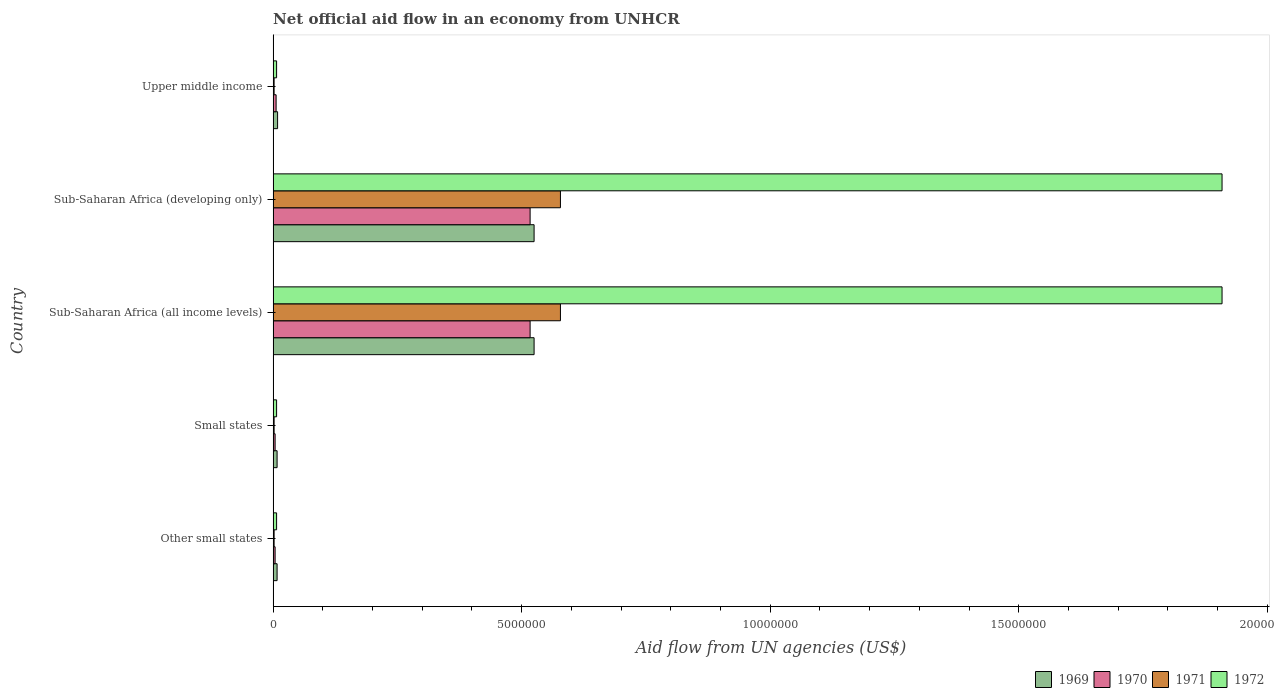How many different coloured bars are there?
Your answer should be compact. 4. How many groups of bars are there?
Offer a terse response. 5. Are the number of bars per tick equal to the number of legend labels?
Your response must be concise. Yes. How many bars are there on the 5th tick from the top?
Keep it short and to the point. 4. How many bars are there on the 5th tick from the bottom?
Your response must be concise. 4. What is the label of the 1st group of bars from the top?
Ensure brevity in your answer.  Upper middle income. What is the net official aid flow in 1970 in Sub-Saharan Africa (developing only)?
Offer a terse response. 5.17e+06. Across all countries, what is the maximum net official aid flow in 1970?
Ensure brevity in your answer.  5.17e+06. In which country was the net official aid flow in 1972 maximum?
Make the answer very short. Sub-Saharan Africa (all income levels). In which country was the net official aid flow in 1972 minimum?
Offer a terse response. Other small states. What is the total net official aid flow in 1971 in the graph?
Keep it short and to the point. 1.16e+07. What is the difference between the net official aid flow in 1970 in Other small states and that in Sub-Saharan Africa (developing only)?
Offer a terse response. -5.13e+06. What is the average net official aid flow in 1972 per country?
Offer a terse response. 7.68e+06. What is the ratio of the net official aid flow in 1970 in Small states to that in Sub-Saharan Africa (all income levels)?
Offer a very short reply. 0.01. What is the difference between the highest and the lowest net official aid flow in 1971?
Give a very brief answer. 5.76e+06. In how many countries, is the net official aid flow in 1972 greater than the average net official aid flow in 1972 taken over all countries?
Offer a very short reply. 2. Is it the case that in every country, the sum of the net official aid flow in 1971 and net official aid flow in 1970 is greater than the sum of net official aid flow in 1972 and net official aid flow in 1969?
Offer a terse response. No. What does the 3rd bar from the top in Sub-Saharan Africa (all income levels) represents?
Provide a short and direct response. 1970. What does the 4th bar from the bottom in Other small states represents?
Provide a short and direct response. 1972. Is it the case that in every country, the sum of the net official aid flow in 1969 and net official aid flow in 1972 is greater than the net official aid flow in 1971?
Offer a very short reply. Yes. How many bars are there?
Keep it short and to the point. 20. Does the graph contain grids?
Make the answer very short. No. How are the legend labels stacked?
Offer a very short reply. Horizontal. What is the title of the graph?
Offer a terse response. Net official aid flow in an economy from UNHCR. What is the label or title of the X-axis?
Your answer should be compact. Aid flow from UN agencies (US$). What is the label or title of the Y-axis?
Give a very brief answer. Country. What is the Aid flow from UN agencies (US$) in 1969 in Other small states?
Your answer should be very brief. 8.00e+04. What is the Aid flow from UN agencies (US$) in 1971 in Other small states?
Offer a very short reply. 2.00e+04. What is the Aid flow from UN agencies (US$) of 1969 in Small states?
Your response must be concise. 8.00e+04. What is the Aid flow from UN agencies (US$) of 1970 in Small states?
Give a very brief answer. 4.00e+04. What is the Aid flow from UN agencies (US$) in 1971 in Small states?
Provide a succinct answer. 2.00e+04. What is the Aid flow from UN agencies (US$) in 1972 in Small states?
Keep it short and to the point. 7.00e+04. What is the Aid flow from UN agencies (US$) of 1969 in Sub-Saharan Africa (all income levels)?
Provide a short and direct response. 5.25e+06. What is the Aid flow from UN agencies (US$) of 1970 in Sub-Saharan Africa (all income levels)?
Offer a very short reply. 5.17e+06. What is the Aid flow from UN agencies (US$) in 1971 in Sub-Saharan Africa (all income levels)?
Offer a terse response. 5.78e+06. What is the Aid flow from UN agencies (US$) in 1972 in Sub-Saharan Africa (all income levels)?
Keep it short and to the point. 1.91e+07. What is the Aid flow from UN agencies (US$) in 1969 in Sub-Saharan Africa (developing only)?
Give a very brief answer. 5.25e+06. What is the Aid flow from UN agencies (US$) in 1970 in Sub-Saharan Africa (developing only)?
Your answer should be compact. 5.17e+06. What is the Aid flow from UN agencies (US$) of 1971 in Sub-Saharan Africa (developing only)?
Your answer should be compact. 5.78e+06. What is the Aid flow from UN agencies (US$) in 1972 in Sub-Saharan Africa (developing only)?
Make the answer very short. 1.91e+07. What is the Aid flow from UN agencies (US$) of 1971 in Upper middle income?
Your answer should be very brief. 2.00e+04. Across all countries, what is the maximum Aid flow from UN agencies (US$) in 1969?
Your answer should be compact. 5.25e+06. Across all countries, what is the maximum Aid flow from UN agencies (US$) of 1970?
Make the answer very short. 5.17e+06. Across all countries, what is the maximum Aid flow from UN agencies (US$) in 1971?
Provide a succinct answer. 5.78e+06. Across all countries, what is the maximum Aid flow from UN agencies (US$) of 1972?
Make the answer very short. 1.91e+07. Across all countries, what is the minimum Aid flow from UN agencies (US$) in 1969?
Ensure brevity in your answer.  8.00e+04. What is the total Aid flow from UN agencies (US$) of 1969 in the graph?
Your answer should be compact. 1.08e+07. What is the total Aid flow from UN agencies (US$) in 1970 in the graph?
Offer a terse response. 1.05e+07. What is the total Aid flow from UN agencies (US$) of 1971 in the graph?
Provide a succinct answer. 1.16e+07. What is the total Aid flow from UN agencies (US$) in 1972 in the graph?
Your answer should be very brief. 3.84e+07. What is the difference between the Aid flow from UN agencies (US$) in 1971 in Other small states and that in Small states?
Give a very brief answer. 0. What is the difference between the Aid flow from UN agencies (US$) of 1969 in Other small states and that in Sub-Saharan Africa (all income levels)?
Make the answer very short. -5.17e+06. What is the difference between the Aid flow from UN agencies (US$) of 1970 in Other small states and that in Sub-Saharan Africa (all income levels)?
Offer a terse response. -5.13e+06. What is the difference between the Aid flow from UN agencies (US$) of 1971 in Other small states and that in Sub-Saharan Africa (all income levels)?
Offer a very short reply. -5.76e+06. What is the difference between the Aid flow from UN agencies (US$) of 1972 in Other small states and that in Sub-Saharan Africa (all income levels)?
Your answer should be very brief. -1.90e+07. What is the difference between the Aid flow from UN agencies (US$) of 1969 in Other small states and that in Sub-Saharan Africa (developing only)?
Provide a succinct answer. -5.17e+06. What is the difference between the Aid flow from UN agencies (US$) in 1970 in Other small states and that in Sub-Saharan Africa (developing only)?
Your answer should be very brief. -5.13e+06. What is the difference between the Aid flow from UN agencies (US$) of 1971 in Other small states and that in Sub-Saharan Africa (developing only)?
Make the answer very short. -5.76e+06. What is the difference between the Aid flow from UN agencies (US$) in 1972 in Other small states and that in Sub-Saharan Africa (developing only)?
Provide a succinct answer. -1.90e+07. What is the difference between the Aid flow from UN agencies (US$) of 1970 in Other small states and that in Upper middle income?
Make the answer very short. -2.00e+04. What is the difference between the Aid flow from UN agencies (US$) of 1969 in Small states and that in Sub-Saharan Africa (all income levels)?
Provide a short and direct response. -5.17e+06. What is the difference between the Aid flow from UN agencies (US$) of 1970 in Small states and that in Sub-Saharan Africa (all income levels)?
Offer a very short reply. -5.13e+06. What is the difference between the Aid flow from UN agencies (US$) in 1971 in Small states and that in Sub-Saharan Africa (all income levels)?
Ensure brevity in your answer.  -5.76e+06. What is the difference between the Aid flow from UN agencies (US$) in 1972 in Small states and that in Sub-Saharan Africa (all income levels)?
Make the answer very short. -1.90e+07. What is the difference between the Aid flow from UN agencies (US$) of 1969 in Small states and that in Sub-Saharan Africa (developing only)?
Ensure brevity in your answer.  -5.17e+06. What is the difference between the Aid flow from UN agencies (US$) in 1970 in Small states and that in Sub-Saharan Africa (developing only)?
Make the answer very short. -5.13e+06. What is the difference between the Aid flow from UN agencies (US$) of 1971 in Small states and that in Sub-Saharan Africa (developing only)?
Your response must be concise. -5.76e+06. What is the difference between the Aid flow from UN agencies (US$) in 1972 in Small states and that in Sub-Saharan Africa (developing only)?
Ensure brevity in your answer.  -1.90e+07. What is the difference between the Aid flow from UN agencies (US$) of 1972 in Small states and that in Upper middle income?
Provide a short and direct response. 0. What is the difference between the Aid flow from UN agencies (US$) in 1969 in Sub-Saharan Africa (all income levels) and that in Sub-Saharan Africa (developing only)?
Ensure brevity in your answer.  0. What is the difference between the Aid flow from UN agencies (US$) in 1970 in Sub-Saharan Africa (all income levels) and that in Sub-Saharan Africa (developing only)?
Ensure brevity in your answer.  0. What is the difference between the Aid flow from UN agencies (US$) of 1969 in Sub-Saharan Africa (all income levels) and that in Upper middle income?
Provide a short and direct response. 5.16e+06. What is the difference between the Aid flow from UN agencies (US$) of 1970 in Sub-Saharan Africa (all income levels) and that in Upper middle income?
Offer a very short reply. 5.11e+06. What is the difference between the Aid flow from UN agencies (US$) in 1971 in Sub-Saharan Africa (all income levels) and that in Upper middle income?
Offer a very short reply. 5.76e+06. What is the difference between the Aid flow from UN agencies (US$) in 1972 in Sub-Saharan Africa (all income levels) and that in Upper middle income?
Provide a succinct answer. 1.90e+07. What is the difference between the Aid flow from UN agencies (US$) of 1969 in Sub-Saharan Africa (developing only) and that in Upper middle income?
Your answer should be very brief. 5.16e+06. What is the difference between the Aid flow from UN agencies (US$) of 1970 in Sub-Saharan Africa (developing only) and that in Upper middle income?
Offer a very short reply. 5.11e+06. What is the difference between the Aid flow from UN agencies (US$) in 1971 in Sub-Saharan Africa (developing only) and that in Upper middle income?
Offer a terse response. 5.76e+06. What is the difference between the Aid flow from UN agencies (US$) in 1972 in Sub-Saharan Africa (developing only) and that in Upper middle income?
Keep it short and to the point. 1.90e+07. What is the difference between the Aid flow from UN agencies (US$) of 1969 in Other small states and the Aid flow from UN agencies (US$) of 1971 in Small states?
Your answer should be very brief. 6.00e+04. What is the difference between the Aid flow from UN agencies (US$) in 1970 in Other small states and the Aid flow from UN agencies (US$) in 1971 in Small states?
Give a very brief answer. 2.00e+04. What is the difference between the Aid flow from UN agencies (US$) in 1970 in Other small states and the Aid flow from UN agencies (US$) in 1972 in Small states?
Ensure brevity in your answer.  -3.00e+04. What is the difference between the Aid flow from UN agencies (US$) of 1969 in Other small states and the Aid flow from UN agencies (US$) of 1970 in Sub-Saharan Africa (all income levels)?
Your response must be concise. -5.09e+06. What is the difference between the Aid flow from UN agencies (US$) of 1969 in Other small states and the Aid flow from UN agencies (US$) of 1971 in Sub-Saharan Africa (all income levels)?
Make the answer very short. -5.70e+06. What is the difference between the Aid flow from UN agencies (US$) of 1969 in Other small states and the Aid flow from UN agencies (US$) of 1972 in Sub-Saharan Africa (all income levels)?
Provide a succinct answer. -1.90e+07. What is the difference between the Aid flow from UN agencies (US$) of 1970 in Other small states and the Aid flow from UN agencies (US$) of 1971 in Sub-Saharan Africa (all income levels)?
Your answer should be very brief. -5.74e+06. What is the difference between the Aid flow from UN agencies (US$) in 1970 in Other small states and the Aid flow from UN agencies (US$) in 1972 in Sub-Saharan Africa (all income levels)?
Offer a very short reply. -1.90e+07. What is the difference between the Aid flow from UN agencies (US$) in 1971 in Other small states and the Aid flow from UN agencies (US$) in 1972 in Sub-Saharan Africa (all income levels)?
Make the answer very short. -1.91e+07. What is the difference between the Aid flow from UN agencies (US$) of 1969 in Other small states and the Aid flow from UN agencies (US$) of 1970 in Sub-Saharan Africa (developing only)?
Provide a short and direct response. -5.09e+06. What is the difference between the Aid flow from UN agencies (US$) of 1969 in Other small states and the Aid flow from UN agencies (US$) of 1971 in Sub-Saharan Africa (developing only)?
Give a very brief answer. -5.70e+06. What is the difference between the Aid flow from UN agencies (US$) in 1969 in Other small states and the Aid flow from UN agencies (US$) in 1972 in Sub-Saharan Africa (developing only)?
Your answer should be compact. -1.90e+07. What is the difference between the Aid flow from UN agencies (US$) in 1970 in Other small states and the Aid flow from UN agencies (US$) in 1971 in Sub-Saharan Africa (developing only)?
Provide a short and direct response. -5.74e+06. What is the difference between the Aid flow from UN agencies (US$) of 1970 in Other small states and the Aid flow from UN agencies (US$) of 1972 in Sub-Saharan Africa (developing only)?
Keep it short and to the point. -1.90e+07. What is the difference between the Aid flow from UN agencies (US$) in 1971 in Other small states and the Aid flow from UN agencies (US$) in 1972 in Sub-Saharan Africa (developing only)?
Make the answer very short. -1.91e+07. What is the difference between the Aid flow from UN agencies (US$) in 1969 in Other small states and the Aid flow from UN agencies (US$) in 1970 in Upper middle income?
Keep it short and to the point. 2.00e+04. What is the difference between the Aid flow from UN agencies (US$) of 1969 in Other small states and the Aid flow from UN agencies (US$) of 1972 in Upper middle income?
Provide a short and direct response. 10000. What is the difference between the Aid flow from UN agencies (US$) of 1969 in Small states and the Aid flow from UN agencies (US$) of 1970 in Sub-Saharan Africa (all income levels)?
Provide a succinct answer. -5.09e+06. What is the difference between the Aid flow from UN agencies (US$) in 1969 in Small states and the Aid flow from UN agencies (US$) in 1971 in Sub-Saharan Africa (all income levels)?
Your answer should be very brief. -5.70e+06. What is the difference between the Aid flow from UN agencies (US$) of 1969 in Small states and the Aid flow from UN agencies (US$) of 1972 in Sub-Saharan Africa (all income levels)?
Your answer should be compact. -1.90e+07. What is the difference between the Aid flow from UN agencies (US$) of 1970 in Small states and the Aid flow from UN agencies (US$) of 1971 in Sub-Saharan Africa (all income levels)?
Provide a short and direct response. -5.74e+06. What is the difference between the Aid flow from UN agencies (US$) of 1970 in Small states and the Aid flow from UN agencies (US$) of 1972 in Sub-Saharan Africa (all income levels)?
Offer a terse response. -1.90e+07. What is the difference between the Aid flow from UN agencies (US$) in 1971 in Small states and the Aid flow from UN agencies (US$) in 1972 in Sub-Saharan Africa (all income levels)?
Keep it short and to the point. -1.91e+07. What is the difference between the Aid flow from UN agencies (US$) in 1969 in Small states and the Aid flow from UN agencies (US$) in 1970 in Sub-Saharan Africa (developing only)?
Ensure brevity in your answer.  -5.09e+06. What is the difference between the Aid flow from UN agencies (US$) in 1969 in Small states and the Aid flow from UN agencies (US$) in 1971 in Sub-Saharan Africa (developing only)?
Your response must be concise. -5.70e+06. What is the difference between the Aid flow from UN agencies (US$) of 1969 in Small states and the Aid flow from UN agencies (US$) of 1972 in Sub-Saharan Africa (developing only)?
Offer a terse response. -1.90e+07. What is the difference between the Aid flow from UN agencies (US$) in 1970 in Small states and the Aid flow from UN agencies (US$) in 1971 in Sub-Saharan Africa (developing only)?
Keep it short and to the point. -5.74e+06. What is the difference between the Aid flow from UN agencies (US$) in 1970 in Small states and the Aid flow from UN agencies (US$) in 1972 in Sub-Saharan Africa (developing only)?
Offer a very short reply. -1.90e+07. What is the difference between the Aid flow from UN agencies (US$) of 1971 in Small states and the Aid flow from UN agencies (US$) of 1972 in Sub-Saharan Africa (developing only)?
Provide a short and direct response. -1.91e+07. What is the difference between the Aid flow from UN agencies (US$) of 1969 in Small states and the Aid flow from UN agencies (US$) of 1971 in Upper middle income?
Your answer should be very brief. 6.00e+04. What is the difference between the Aid flow from UN agencies (US$) of 1970 in Small states and the Aid flow from UN agencies (US$) of 1971 in Upper middle income?
Offer a terse response. 2.00e+04. What is the difference between the Aid flow from UN agencies (US$) in 1970 in Small states and the Aid flow from UN agencies (US$) in 1972 in Upper middle income?
Your answer should be very brief. -3.00e+04. What is the difference between the Aid flow from UN agencies (US$) in 1971 in Small states and the Aid flow from UN agencies (US$) in 1972 in Upper middle income?
Offer a very short reply. -5.00e+04. What is the difference between the Aid flow from UN agencies (US$) in 1969 in Sub-Saharan Africa (all income levels) and the Aid flow from UN agencies (US$) in 1971 in Sub-Saharan Africa (developing only)?
Your response must be concise. -5.30e+05. What is the difference between the Aid flow from UN agencies (US$) of 1969 in Sub-Saharan Africa (all income levels) and the Aid flow from UN agencies (US$) of 1972 in Sub-Saharan Africa (developing only)?
Ensure brevity in your answer.  -1.38e+07. What is the difference between the Aid flow from UN agencies (US$) in 1970 in Sub-Saharan Africa (all income levels) and the Aid flow from UN agencies (US$) in 1971 in Sub-Saharan Africa (developing only)?
Offer a terse response. -6.10e+05. What is the difference between the Aid flow from UN agencies (US$) of 1970 in Sub-Saharan Africa (all income levels) and the Aid flow from UN agencies (US$) of 1972 in Sub-Saharan Africa (developing only)?
Offer a very short reply. -1.39e+07. What is the difference between the Aid flow from UN agencies (US$) in 1971 in Sub-Saharan Africa (all income levels) and the Aid flow from UN agencies (US$) in 1972 in Sub-Saharan Africa (developing only)?
Your response must be concise. -1.33e+07. What is the difference between the Aid flow from UN agencies (US$) in 1969 in Sub-Saharan Africa (all income levels) and the Aid flow from UN agencies (US$) in 1970 in Upper middle income?
Your response must be concise. 5.19e+06. What is the difference between the Aid flow from UN agencies (US$) of 1969 in Sub-Saharan Africa (all income levels) and the Aid flow from UN agencies (US$) of 1971 in Upper middle income?
Provide a succinct answer. 5.23e+06. What is the difference between the Aid flow from UN agencies (US$) in 1969 in Sub-Saharan Africa (all income levels) and the Aid flow from UN agencies (US$) in 1972 in Upper middle income?
Your response must be concise. 5.18e+06. What is the difference between the Aid flow from UN agencies (US$) of 1970 in Sub-Saharan Africa (all income levels) and the Aid flow from UN agencies (US$) of 1971 in Upper middle income?
Your response must be concise. 5.15e+06. What is the difference between the Aid flow from UN agencies (US$) in 1970 in Sub-Saharan Africa (all income levels) and the Aid flow from UN agencies (US$) in 1972 in Upper middle income?
Give a very brief answer. 5.10e+06. What is the difference between the Aid flow from UN agencies (US$) of 1971 in Sub-Saharan Africa (all income levels) and the Aid flow from UN agencies (US$) of 1972 in Upper middle income?
Make the answer very short. 5.71e+06. What is the difference between the Aid flow from UN agencies (US$) in 1969 in Sub-Saharan Africa (developing only) and the Aid flow from UN agencies (US$) in 1970 in Upper middle income?
Ensure brevity in your answer.  5.19e+06. What is the difference between the Aid flow from UN agencies (US$) in 1969 in Sub-Saharan Africa (developing only) and the Aid flow from UN agencies (US$) in 1971 in Upper middle income?
Ensure brevity in your answer.  5.23e+06. What is the difference between the Aid flow from UN agencies (US$) in 1969 in Sub-Saharan Africa (developing only) and the Aid flow from UN agencies (US$) in 1972 in Upper middle income?
Provide a succinct answer. 5.18e+06. What is the difference between the Aid flow from UN agencies (US$) in 1970 in Sub-Saharan Africa (developing only) and the Aid flow from UN agencies (US$) in 1971 in Upper middle income?
Keep it short and to the point. 5.15e+06. What is the difference between the Aid flow from UN agencies (US$) in 1970 in Sub-Saharan Africa (developing only) and the Aid flow from UN agencies (US$) in 1972 in Upper middle income?
Your answer should be compact. 5.10e+06. What is the difference between the Aid flow from UN agencies (US$) of 1971 in Sub-Saharan Africa (developing only) and the Aid flow from UN agencies (US$) of 1972 in Upper middle income?
Offer a terse response. 5.71e+06. What is the average Aid flow from UN agencies (US$) in 1969 per country?
Your answer should be compact. 2.15e+06. What is the average Aid flow from UN agencies (US$) of 1970 per country?
Keep it short and to the point. 2.10e+06. What is the average Aid flow from UN agencies (US$) in 1971 per country?
Provide a short and direct response. 2.32e+06. What is the average Aid flow from UN agencies (US$) of 1972 per country?
Provide a short and direct response. 7.68e+06. What is the difference between the Aid flow from UN agencies (US$) in 1969 and Aid flow from UN agencies (US$) in 1970 in Other small states?
Provide a succinct answer. 4.00e+04. What is the difference between the Aid flow from UN agencies (US$) in 1969 and Aid flow from UN agencies (US$) in 1971 in Other small states?
Keep it short and to the point. 6.00e+04. What is the difference between the Aid flow from UN agencies (US$) of 1969 and Aid flow from UN agencies (US$) of 1972 in Other small states?
Keep it short and to the point. 10000. What is the difference between the Aid flow from UN agencies (US$) of 1970 and Aid flow from UN agencies (US$) of 1971 in Other small states?
Ensure brevity in your answer.  2.00e+04. What is the difference between the Aid flow from UN agencies (US$) in 1971 and Aid flow from UN agencies (US$) in 1972 in Other small states?
Offer a very short reply. -5.00e+04. What is the difference between the Aid flow from UN agencies (US$) in 1969 and Aid flow from UN agencies (US$) in 1970 in Small states?
Ensure brevity in your answer.  4.00e+04. What is the difference between the Aid flow from UN agencies (US$) of 1969 and Aid flow from UN agencies (US$) of 1971 in Small states?
Your answer should be compact. 6.00e+04. What is the difference between the Aid flow from UN agencies (US$) in 1970 and Aid flow from UN agencies (US$) in 1971 in Small states?
Your answer should be compact. 2.00e+04. What is the difference between the Aid flow from UN agencies (US$) in 1969 and Aid flow from UN agencies (US$) in 1971 in Sub-Saharan Africa (all income levels)?
Your response must be concise. -5.30e+05. What is the difference between the Aid flow from UN agencies (US$) in 1969 and Aid flow from UN agencies (US$) in 1972 in Sub-Saharan Africa (all income levels)?
Provide a short and direct response. -1.38e+07. What is the difference between the Aid flow from UN agencies (US$) in 1970 and Aid flow from UN agencies (US$) in 1971 in Sub-Saharan Africa (all income levels)?
Offer a very short reply. -6.10e+05. What is the difference between the Aid flow from UN agencies (US$) of 1970 and Aid flow from UN agencies (US$) of 1972 in Sub-Saharan Africa (all income levels)?
Keep it short and to the point. -1.39e+07. What is the difference between the Aid flow from UN agencies (US$) of 1971 and Aid flow from UN agencies (US$) of 1972 in Sub-Saharan Africa (all income levels)?
Provide a succinct answer. -1.33e+07. What is the difference between the Aid flow from UN agencies (US$) of 1969 and Aid flow from UN agencies (US$) of 1970 in Sub-Saharan Africa (developing only)?
Offer a terse response. 8.00e+04. What is the difference between the Aid flow from UN agencies (US$) of 1969 and Aid flow from UN agencies (US$) of 1971 in Sub-Saharan Africa (developing only)?
Keep it short and to the point. -5.30e+05. What is the difference between the Aid flow from UN agencies (US$) in 1969 and Aid flow from UN agencies (US$) in 1972 in Sub-Saharan Africa (developing only)?
Your answer should be very brief. -1.38e+07. What is the difference between the Aid flow from UN agencies (US$) of 1970 and Aid flow from UN agencies (US$) of 1971 in Sub-Saharan Africa (developing only)?
Offer a very short reply. -6.10e+05. What is the difference between the Aid flow from UN agencies (US$) in 1970 and Aid flow from UN agencies (US$) in 1972 in Sub-Saharan Africa (developing only)?
Give a very brief answer. -1.39e+07. What is the difference between the Aid flow from UN agencies (US$) of 1971 and Aid flow from UN agencies (US$) of 1972 in Sub-Saharan Africa (developing only)?
Keep it short and to the point. -1.33e+07. What is the difference between the Aid flow from UN agencies (US$) of 1969 and Aid flow from UN agencies (US$) of 1970 in Upper middle income?
Your answer should be very brief. 3.00e+04. What is the difference between the Aid flow from UN agencies (US$) of 1969 and Aid flow from UN agencies (US$) of 1972 in Upper middle income?
Offer a very short reply. 2.00e+04. What is the difference between the Aid flow from UN agencies (US$) in 1970 and Aid flow from UN agencies (US$) in 1971 in Upper middle income?
Provide a short and direct response. 4.00e+04. What is the difference between the Aid flow from UN agencies (US$) of 1971 and Aid flow from UN agencies (US$) of 1972 in Upper middle income?
Provide a succinct answer. -5.00e+04. What is the ratio of the Aid flow from UN agencies (US$) of 1969 in Other small states to that in Small states?
Ensure brevity in your answer.  1. What is the ratio of the Aid flow from UN agencies (US$) of 1970 in Other small states to that in Small states?
Provide a succinct answer. 1. What is the ratio of the Aid flow from UN agencies (US$) in 1971 in Other small states to that in Small states?
Your answer should be compact. 1. What is the ratio of the Aid flow from UN agencies (US$) in 1972 in Other small states to that in Small states?
Offer a terse response. 1. What is the ratio of the Aid flow from UN agencies (US$) in 1969 in Other small states to that in Sub-Saharan Africa (all income levels)?
Ensure brevity in your answer.  0.02. What is the ratio of the Aid flow from UN agencies (US$) of 1970 in Other small states to that in Sub-Saharan Africa (all income levels)?
Offer a very short reply. 0.01. What is the ratio of the Aid flow from UN agencies (US$) of 1971 in Other small states to that in Sub-Saharan Africa (all income levels)?
Keep it short and to the point. 0. What is the ratio of the Aid flow from UN agencies (US$) of 1972 in Other small states to that in Sub-Saharan Africa (all income levels)?
Keep it short and to the point. 0. What is the ratio of the Aid flow from UN agencies (US$) of 1969 in Other small states to that in Sub-Saharan Africa (developing only)?
Give a very brief answer. 0.02. What is the ratio of the Aid flow from UN agencies (US$) in 1970 in Other small states to that in Sub-Saharan Africa (developing only)?
Your answer should be compact. 0.01. What is the ratio of the Aid flow from UN agencies (US$) of 1971 in Other small states to that in Sub-Saharan Africa (developing only)?
Make the answer very short. 0. What is the ratio of the Aid flow from UN agencies (US$) in 1972 in Other small states to that in Sub-Saharan Africa (developing only)?
Provide a short and direct response. 0. What is the ratio of the Aid flow from UN agencies (US$) in 1969 in Other small states to that in Upper middle income?
Give a very brief answer. 0.89. What is the ratio of the Aid flow from UN agencies (US$) of 1970 in Other small states to that in Upper middle income?
Make the answer very short. 0.67. What is the ratio of the Aid flow from UN agencies (US$) in 1971 in Other small states to that in Upper middle income?
Offer a terse response. 1. What is the ratio of the Aid flow from UN agencies (US$) in 1972 in Other small states to that in Upper middle income?
Keep it short and to the point. 1. What is the ratio of the Aid flow from UN agencies (US$) of 1969 in Small states to that in Sub-Saharan Africa (all income levels)?
Offer a terse response. 0.02. What is the ratio of the Aid flow from UN agencies (US$) in 1970 in Small states to that in Sub-Saharan Africa (all income levels)?
Your answer should be very brief. 0.01. What is the ratio of the Aid flow from UN agencies (US$) of 1971 in Small states to that in Sub-Saharan Africa (all income levels)?
Provide a succinct answer. 0. What is the ratio of the Aid flow from UN agencies (US$) in 1972 in Small states to that in Sub-Saharan Africa (all income levels)?
Offer a very short reply. 0. What is the ratio of the Aid flow from UN agencies (US$) of 1969 in Small states to that in Sub-Saharan Africa (developing only)?
Give a very brief answer. 0.02. What is the ratio of the Aid flow from UN agencies (US$) of 1970 in Small states to that in Sub-Saharan Africa (developing only)?
Your answer should be very brief. 0.01. What is the ratio of the Aid flow from UN agencies (US$) in 1971 in Small states to that in Sub-Saharan Africa (developing only)?
Provide a short and direct response. 0. What is the ratio of the Aid flow from UN agencies (US$) of 1972 in Small states to that in Sub-Saharan Africa (developing only)?
Your answer should be very brief. 0. What is the ratio of the Aid flow from UN agencies (US$) of 1970 in Small states to that in Upper middle income?
Your answer should be compact. 0.67. What is the ratio of the Aid flow from UN agencies (US$) of 1972 in Small states to that in Upper middle income?
Provide a succinct answer. 1. What is the ratio of the Aid flow from UN agencies (US$) in 1970 in Sub-Saharan Africa (all income levels) to that in Sub-Saharan Africa (developing only)?
Your response must be concise. 1. What is the ratio of the Aid flow from UN agencies (US$) of 1972 in Sub-Saharan Africa (all income levels) to that in Sub-Saharan Africa (developing only)?
Keep it short and to the point. 1. What is the ratio of the Aid flow from UN agencies (US$) in 1969 in Sub-Saharan Africa (all income levels) to that in Upper middle income?
Offer a very short reply. 58.33. What is the ratio of the Aid flow from UN agencies (US$) of 1970 in Sub-Saharan Africa (all income levels) to that in Upper middle income?
Give a very brief answer. 86.17. What is the ratio of the Aid flow from UN agencies (US$) of 1971 in Sub-Saharan Africa (all income levels) to that in Upper middle income?
Your answer should be very brief. 289. What is the ratio of the Aid flow from UN agencies (US$) of 1972 in Sub-Saharan Africa (all income levels) to that in Upper middle income?
Give a very brief answer. 272.71. What is the ratio of the Aid flow from UN agencies (US$) of 1969 in Sub-Saharan Africa (developing only) to that in Upper middle income?
Keep it short and to the point. 58.33. What is the ratio of the Aid flow from UN agencies (US$) in 1970 in Sub-Saharan Africa (developing only) to that in Upper middle income?
Provide a succinct answer. 86.17. What is the ratio of the Aid flow from UN agencies (US$) in 1971 in Sub-Saharan Africa (developing only) to that in Upper middle income?
Offer a terse response. 289. What is the ratio of the Aid flow from UN agencies (US$) in 1972 in Sub-Saharan Africa (developing only) to that in Upper middle income?
Provide a succinct answer. 272.71. What is the difference between the highest and the lowest Aid flow from UN agencies (US$) in 1969?
Your answer should be very brief. 5.17e+06. What is the difference between the highest and the lowest Aid flow from UN agencies (US$) of 1970?
Your response must be concise. 5.13e+06. What is the difference between the highest and the lowest Aid flow from UN agencies (US$) of 1971?
Offer a terse response. 5.76e+06. What is the difference between the highest and the lowest Aid flow from UN agencies (US$) in 1972?
Give a very brief answer. 1.90e+07. 